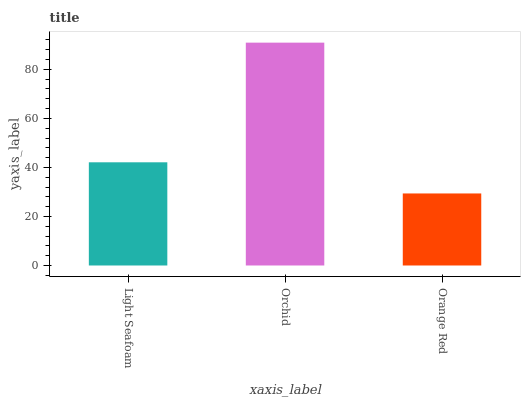Is Orange Red the minimum?
Answer yes or no. Yes. Is Orchid the maximum?
Answer yes or no. Yes. Is Orchid the minimum?
Answer yes or no. No. Is Orange Red the maximum?
Answer yes or no. No. Is Orchid greater than Orange Red?
Answer yes or no. Yes. Is Orange Red less than Orchid?
Answer yes or no. Yes. Is Orange Red greater than Orchid?
Answer yes or no. No. Is Orchid less than Orange Red?
Answer yes or no. No. Is Light Seafoam the high median?
Answer yes or no. Yes. Is Light Seafoam the low median?
Answer yes or no. Yes. Is Orchid the high median?
Answer yes or no. No. Is Orange Red the low median?
Answer yes or no. No. 